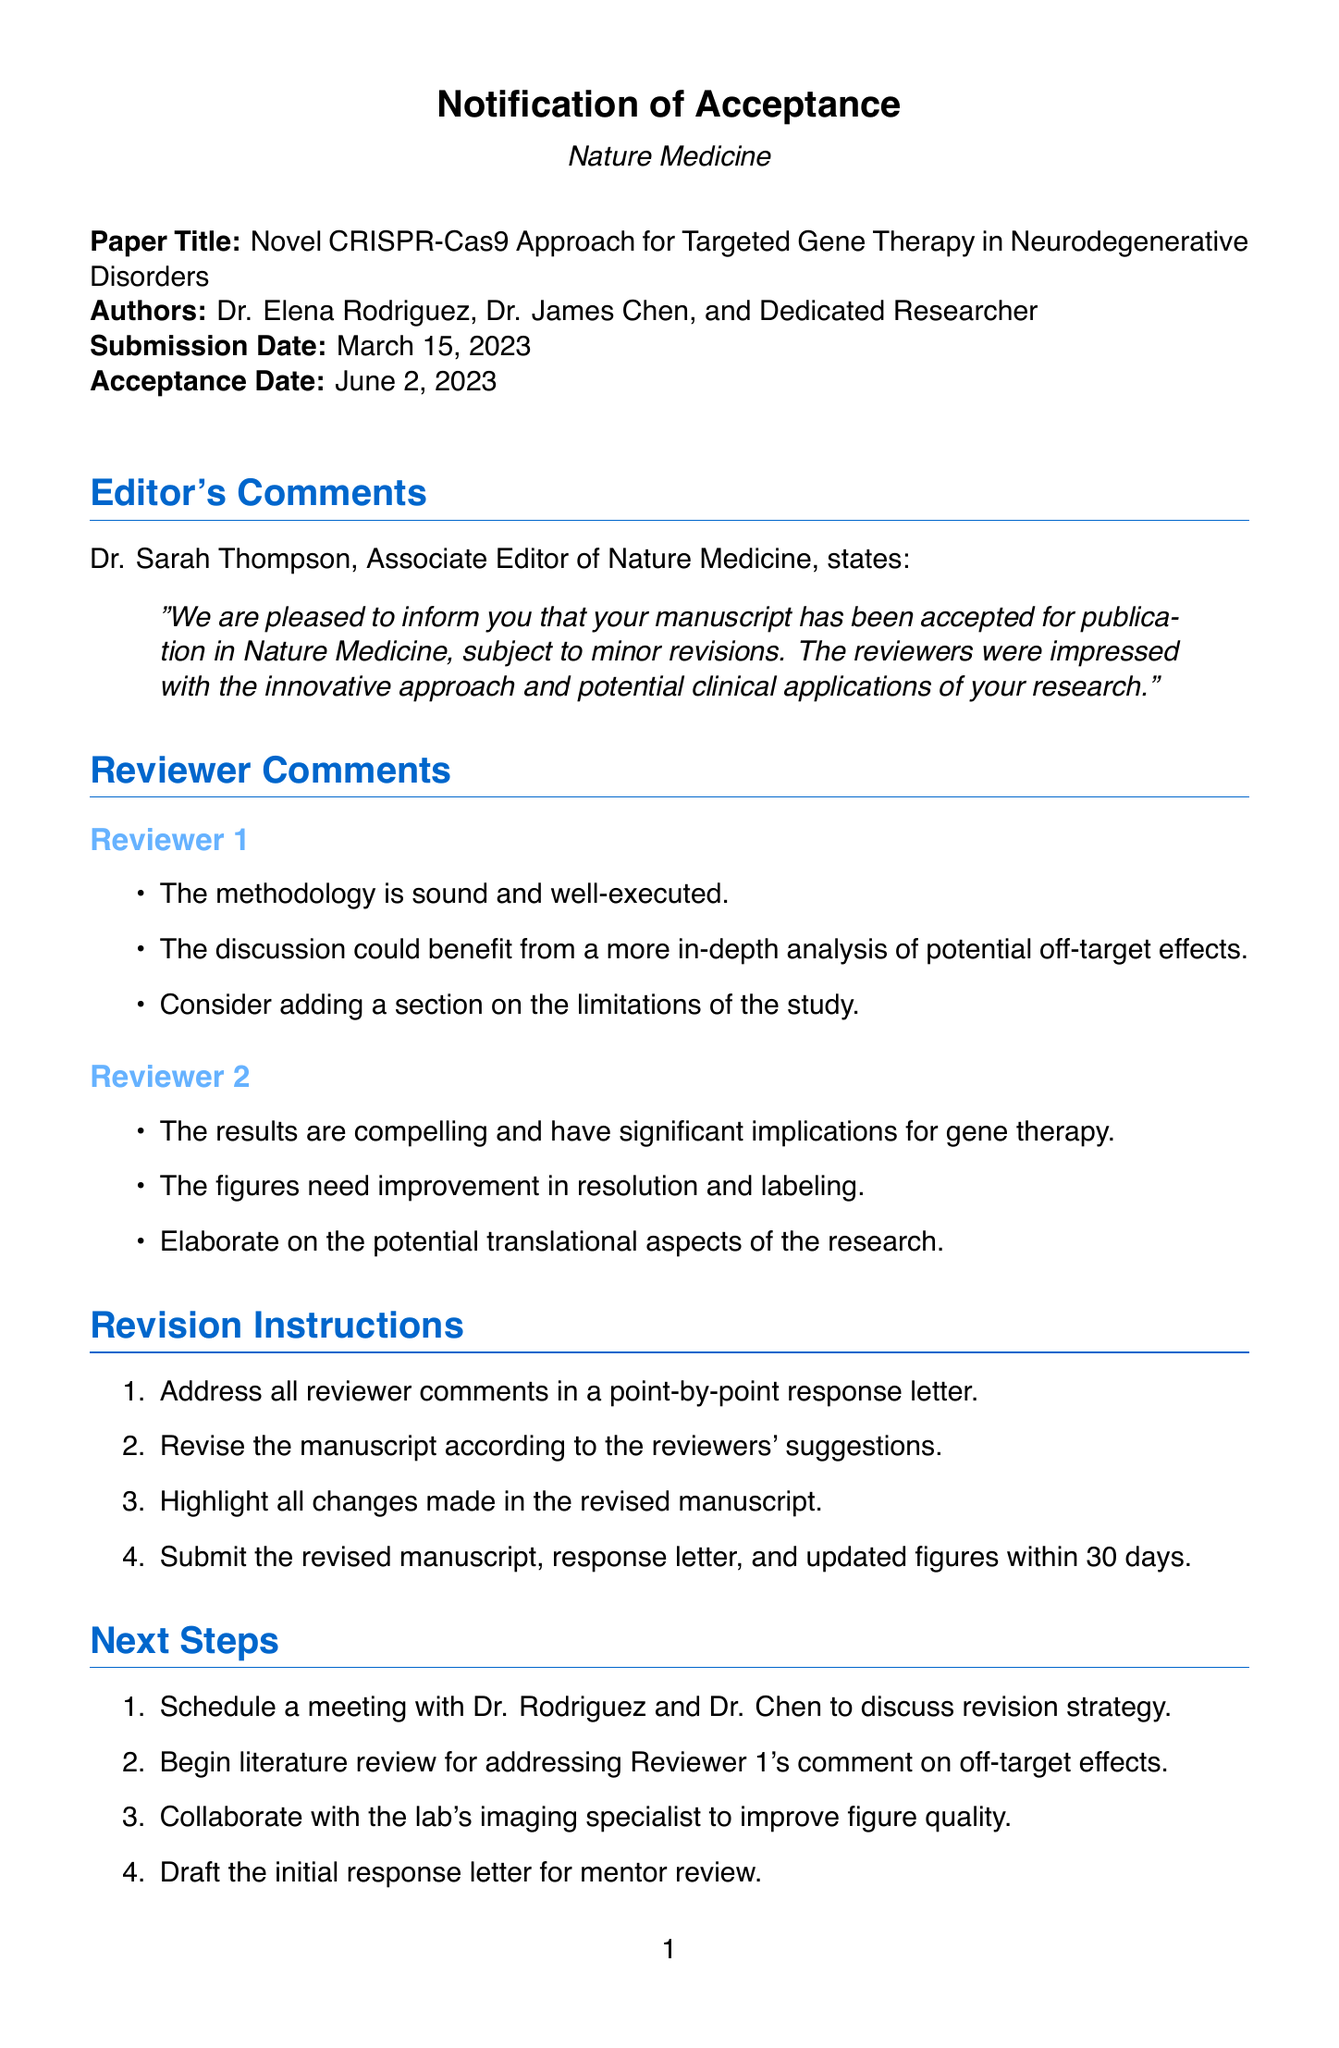What is the title of the paper? The title of the paper is explicitly mentioned in the document as "Novel CRISPR-Cas9 Approach for Targeted Gene Therapy in Neurodegenerative Disorders."
Answer: Novel CRISPR-Cas9 Approach for Targeted Gene Therapy in Neurodegenerative Disorders Who is the Associate Editor of Nature Medicine? The document states that Dr. Sarah Thompson is the Associate Editor, which is explicitly provided in the editor's comments section.
Answer: Dr. Sarah Thompson When was the manuscript accepted? The acceptance date is directly stated in the document, mentioned clearly under the paper details section.
Answer: June 2, 2023 How many reviewers provided comments? The document lists comments from two reviewers, which can be counted from the reviewer comments section.
Answer: 2 What is one of the suggestions made by Reviewer 1? The document includes specific comments made by Reviewer 1, which details suggestions regarding the discussion area.
Answer: More in-depth analysis of potential off-target effects What should be highlighted in the revised manuscript? The revision instructions include specific requirements on what changes should be highlighted in the manuscript.
Answer: All changes made What is a next step mentioned in the document? The next steps section lists actions to be taken after acceptance, and each point is a suggested action to follow.
Answer: Schedule a meeting with Dr. Rodriguez and Dr. Chen What is the impact factor of the journal? The document states the impact factor of Nature Medicine, which is a specific metric provided in the details.
Answer: 53.44 What are the potential clinical applications mentioned? Potential clinical applications are clearly defined in the document, summarizing the expected outcomes of the research.
Answer: Possible new treatments for Alzheimer's and Parkinson's diseases 